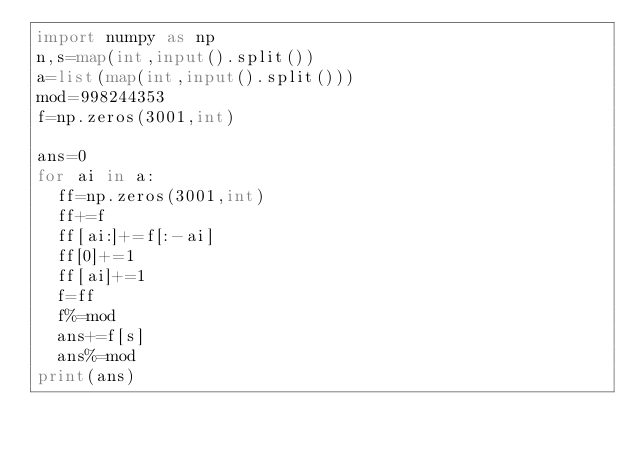<code> <loc_0><loc_0><loc_500><loc_500><_Python_>import numpy as np
n,s=map(int,input().split())
a=list(map(int,input().split()))
mod=998244353
f=np.zeros(3001,int)

ans=0
for ai in a:
  ff=np.zeros(3001,int)
  ff+=f
  ff[ai:]+=f[:-ai]
  ff[0]+=1
  ff[ai]+=1
  f=ff
  f%=mod
  ans+=f[s]
  ans%=mod
print(ans)

</code> 